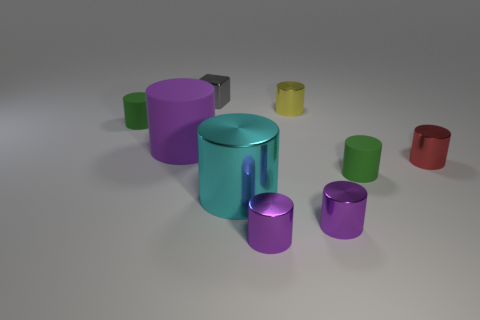What material is the big cyan thing that is the same shape as the red thing?
Provide a short and direct response. Metal. How many other things are the same color as the big matte cylinder?
Provide a succinct answer. 2. Are there more yellow metallic things than big yellow matte cubes?
Offer a terse response. Yes. What is the red cylinder made of?
Your response must be concise. Metal. Do the green cylinder that is to the left of the yellow metallic cylinder and the small yellow cylinder have the same size?
Offer a terse response. Yes. What is the size of the purple shiny cylinder that is to the left of the yellow shiny cylinder?
Offer a terse response. Small. How many small purple cylinders are there?
Your answer should be compact. 2. What is the color of the object that is behind the large purple rubber thing and left of the tiny gray cube?
Keep it short and to the point. Green. Are there any shiny things behind the tiny red object?
Offer a terse response. Yes. What number of gray metallic things are behind the tiny matte cylinder that is behind the red cylinder?
Offer a terse response. 1. 